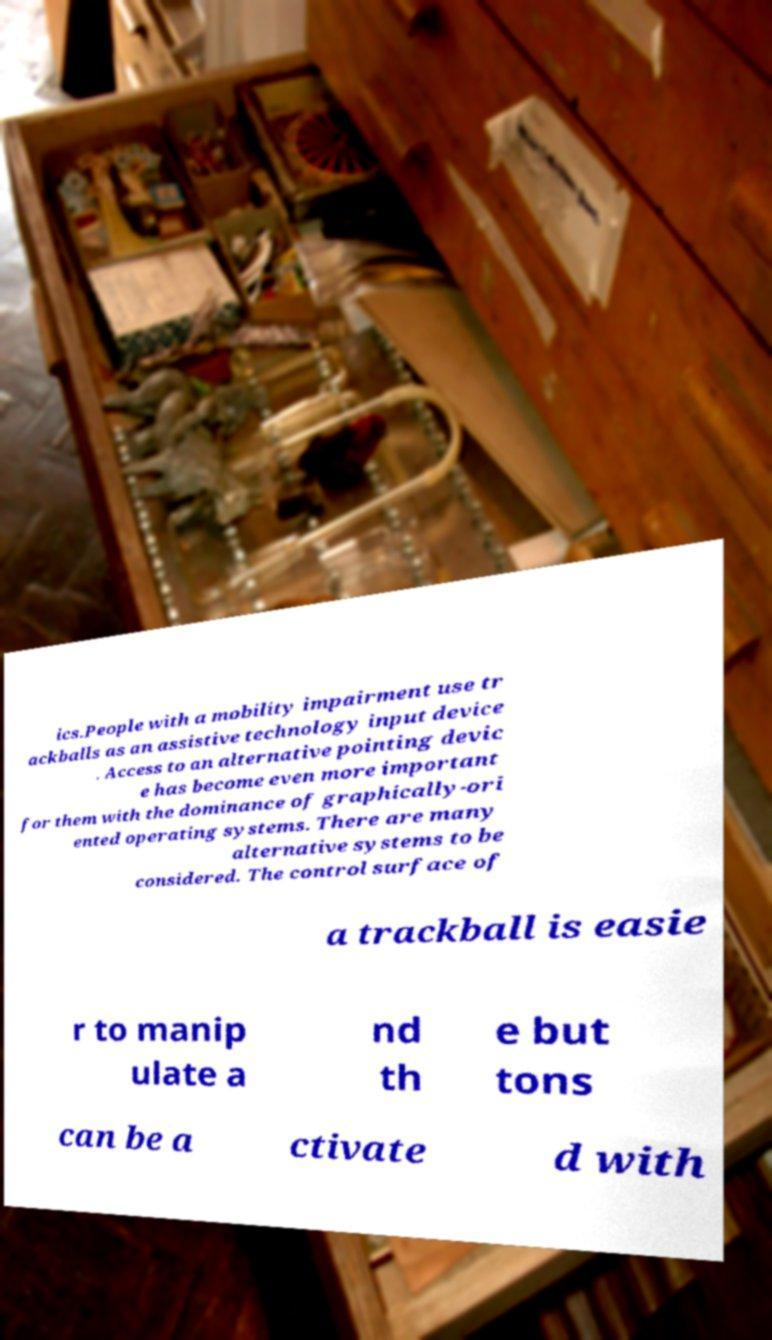Could you assist in decoding the text presented in this image and type it out clearly? ics.People with a mobility impairment use tr ackballs as an assistive technology input device . Access to an alternative pointing devic e has become even more important for them with the dominance of graphically-ori ented operating systems. There are many alternative systems to be considered. The control surface of a trackball is easie r to manip ulate a nd th e but tons can be a ctivate d with 